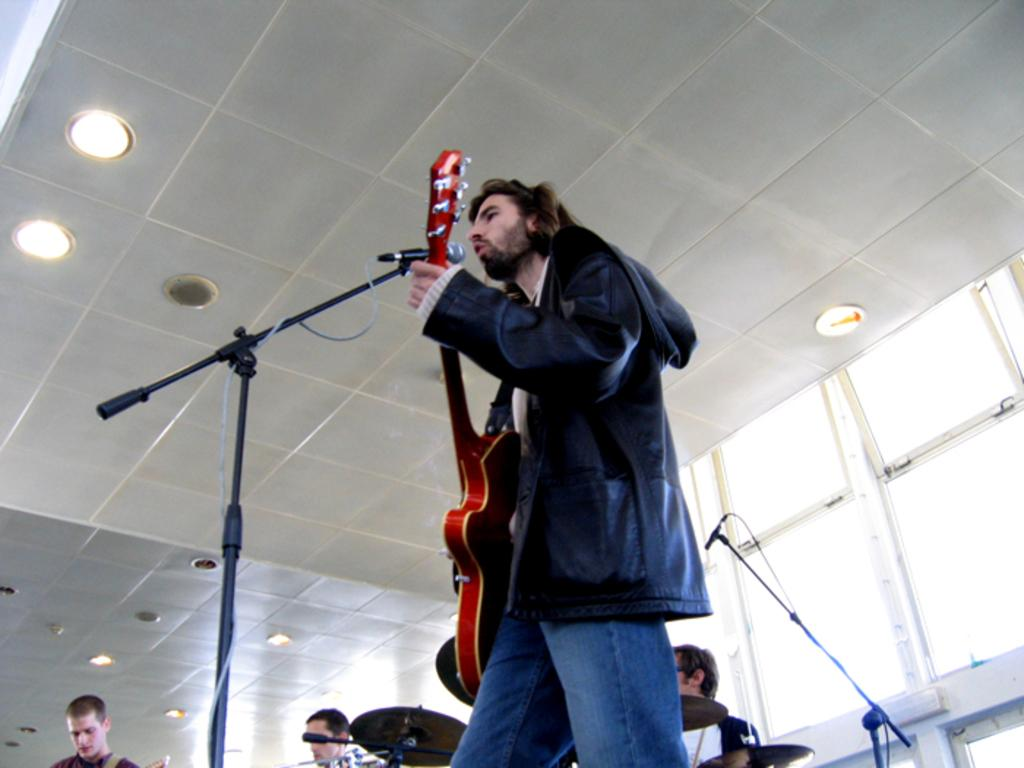What is the man in the image doing? The man is playing a guitar and singing in the image. What object is the man using to amplify his voice? There is a microphone in the image. How many people are in the background of the image? There are three persons in the background of the image. What can be seen in the image that provides illumination? There is a light in the image. What type of current is flowing through the bridge in the image? There is no bridge present in the image, so it is not possible to determine the type of current flowing through it. 